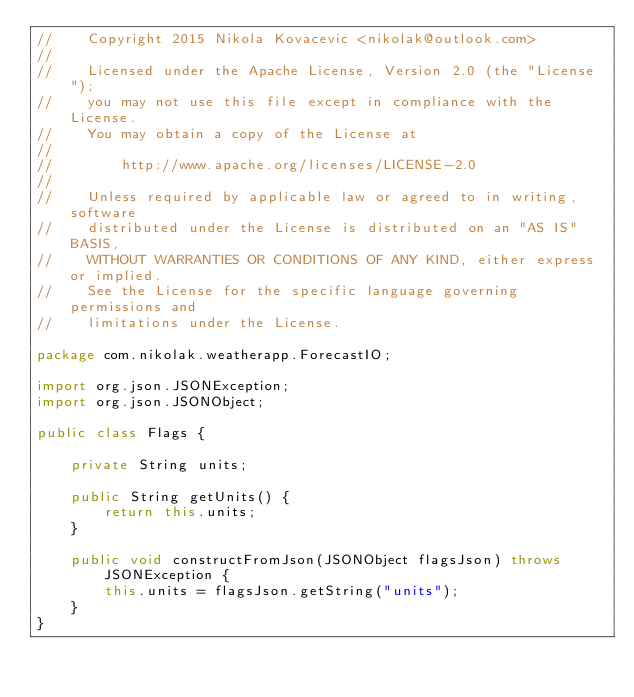<code> <loc_0><loc_0><loc_500><loc_500><_Java_>//    Copyright 2015 Nikola Kovacevic <nikolak@outlook.com>
//
//    Licensed under the Apache License, Version 2.0 (the "License");
//    you may not use this file except in compliance with the License.
//    You may obtain a copy of the License at
//
//        http://www.apache.org/licenses/LICENSE-2.0
//
//    Unless required by applicable law or agreed to in writing, software
//    distributed under the License is distributed on an "AS IS" BASIS,
//    WITHOUT WARRANTIES OR CONDITIONS OF ANY KIND, either express or implied.
//    See the License for the specific language governing permissions and
//    limitations under the License.

package com.nikolak.weatherapp.ForecastIO;

import org.json.JSONException;
import org.json.JSONObject;

public class Flags {

    private String units;

    public String getUnits() {
        return this.units;
    }

    public void constructFromJson(JSONObject flagsJson) throws JSONException {
        this.units = flagsJson.getString("units");
    }
}
</code> 